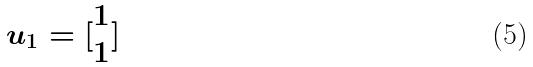Convert formula to latex. <formula><loc_0><loc_0><loc_500><loc_500>u _ { 1 } = [ \begin{matrix} 1 \\ 1 \end{matrix} ]</formula> 